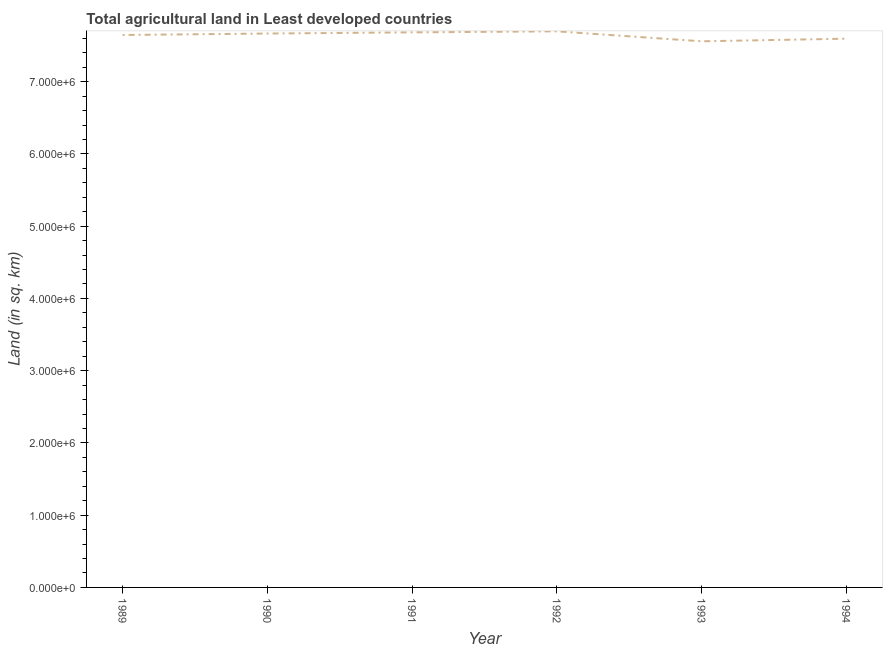What is the agricultural land in 1993?
Make the answer very short. 7.56e+06. Across all years, what is the maximum agricultural land?
Give a very brief answer. 7.70e+06. Across all years, what is the minimum agricultural land?
Your answer should be compact. 7.56e+06. In which year was the agricultural land maximum?
Keep it short and to the point. 1992. In which year was the agricultural land minimum?
Offer a terse response. 1993. What is the sum of the agricultural land?
Provide a short and direct response. 4.58e+07. What is the difference between the agricultural land in 1989 and 1990?
Give a very brief answer. -2.04e+04. What is the average agricultural land per year?
Keep it short and to the point. 7.64e+06. What is the median agricultural land?
Your response must be concise. 7.66e+06. Do a majority of the years between 1990 and 1994 (inclusive) have agricultural land greater than 3800000 sq. km?
Offer a very short reply. Yes. What is the ratio of the agricultural land in 1989 to that in 1990?
Your answer should be compact. 1. What is the difference between the highest and the second highest agricultural land?
Make the answer very short. 1.46e+04. Is the sum of the agricultural land in 1989 and 1994 greater than the maximum agricultural land across all years?
Provide a short and direct response. Yes. What is the difference between the highest and the lowest agricultural land?
Make the answer very short. 1.38e+05. Does the agricultural land monotonically increase over the years?
Make the answer very short. No. Does the graph contain grids?
Keep it short and to the point. No. What is the title of the graph?
Provide a short and direct response. Total agricultural land in Least developed countries. What is the label or title of the Y-axis?
Your response must be concise. Land (in sq. km). What is the Land (in sq. km) of 1989?
Provide a succinct answer. 7.65e+06. What is the Land (in sq. km) in 1990?
Make the answer very short. 7.67e+06. What is the Land (in sq. km) of 1991?
Ensure brevity in your answer.  7.68e+06. What is the Land (in sq. km) of 1992?
Make the answer very short. 7.70e+06. What is the Land (in sq. km) in 1993?
Your response must be concise. 7.56e+06. What is the Land (in sq. km) in 1994?
Offer a very short reply. 7.59e+06. What is the difference between the Land (in sq. km) in 1989 and 1990?
Provide a short and direct response. -2.04e+04. What is the difference between the Land (in sq. km) in 1989 and 1991?
Make the answer very short. -3.63e+04. What is the difference between the Land (in sq. km) in 1989 and 1992?
Offer a very short reply. -5.09e+04. What is the difference between the Land (in sq. km) in 1989 and 1993?
Your answer should be compact. 8.72e+04. What is the difference between the Land (in sq. km) in 1989 and 1994?
Your answer should be very brief. 5.10e+04. What is the difference between the Land (in sq. km) in 1990 and 1991?
Ensure brevity in your answer.  -1.59e+04. What is the difference between the Land (in sq. km) in 1990 and 1992?
Your response must be concise. -3.05e+04. What is the difference between the Land (in sq. km) in 1990 and 1993?
Make the answer very short. 1.08e+05. What is the difference between the Land (in sq. km) in 1990 and 1994?
Make the answer very short. 7.14e+04. What is the difference between the Land (in sq. km) in 1991 and 1992?
Offer a very short reply. -1.46e+04. What is the difference between the Land (in sq. km) in 1991 and 1993?
Provide a succinct answer. 1.24e+05. What is the difference between the Land (in sq. km) in 1991 and 1994?
Give a very brief answer. 8.73e+04. What is the difference between the Land (in sq. km) in 1992 and 1993?
Your response must be concise. 1.38e+05. What is the difference between the Land (in sq. km) in 1992 and 1994?
Provide a short and direct response. 1.02e+05. What is the difference between the Land (in sq. km) in 1993 and 1994?
Provide a short and direct response. -3.62e+04. What is the ratio of the Land (in sq. km) in 1989 to that in 1992?
Provide a short and direct response. 0.99. What is the ratio of the Land (in sq. km) in 1989 to that in 1993?
Make the answer very short. 1.01. What is the ratio of the Land (in sq. km) in 1990 to that in 1992?
Provide a short and direct response. 1. What is the ratio of the Land (in sq. km) in 1990 to that in 1993?
Your answer should be very brief. 1.01. What is the ratio of the Land (in sq. km) in 1990 to that in 1994?
Your answer should be compact. 1.01. What is the ratio of the Land (in sq. km) in 1991 to that in 1994?
Provide a succinct answer. 1.01. What is the ratio of the Land (in sq. km) in 1992 to that in 1993?
Provide a succinct answer. 1.02. 